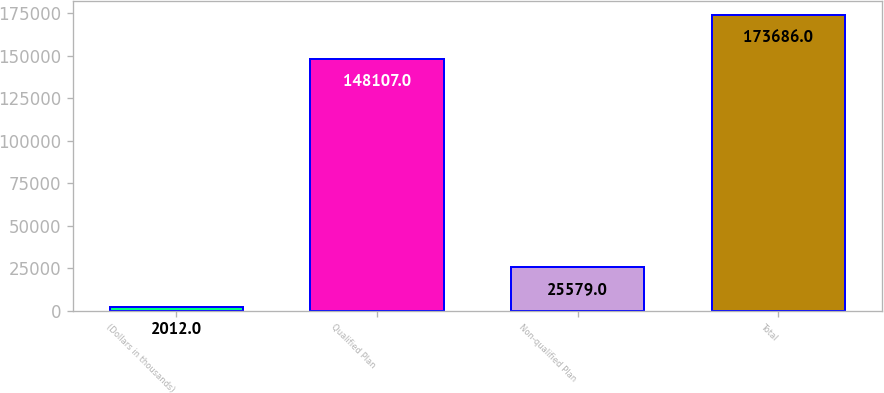Convert chart. <chart><loc_0><loc_0><loc_500><loc_500><bar_chart><fcel>(Dollars in thousands)<fcel>Qualified Plan<fcel>Non-qualified Plan<fcel>Total<nl><fcel>2012<fcel>148107<fcel>25579<fcel>173686<nl></chart> 